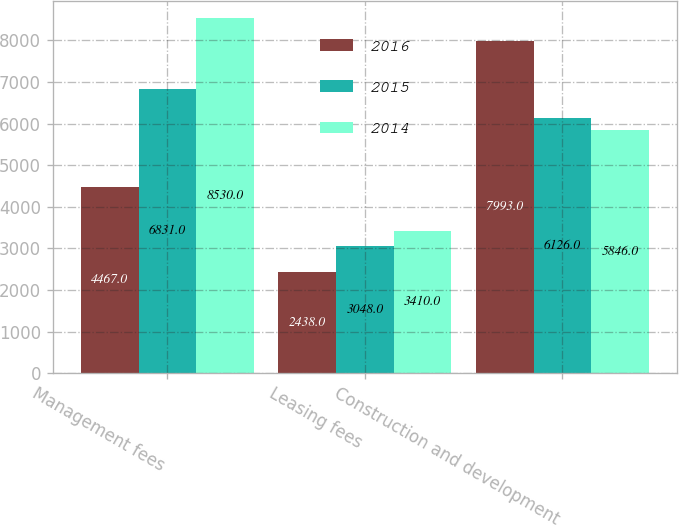<chart> <loc_0><loc_0><loc_500><loc_500><stacked_bar_chart><ecel><fcel>Management fees<fcel>Leasing fees<fcel>Construction and development<nl><fcel>2016<fcel>4467<fcel>2438<fcel>7993<nl><fcel>2015<fcel>6831<fcel>3048<fcel>6126<nl><fcel>2014<fcel>8530<fcel>3410<fcel>5846<nl></chart> 